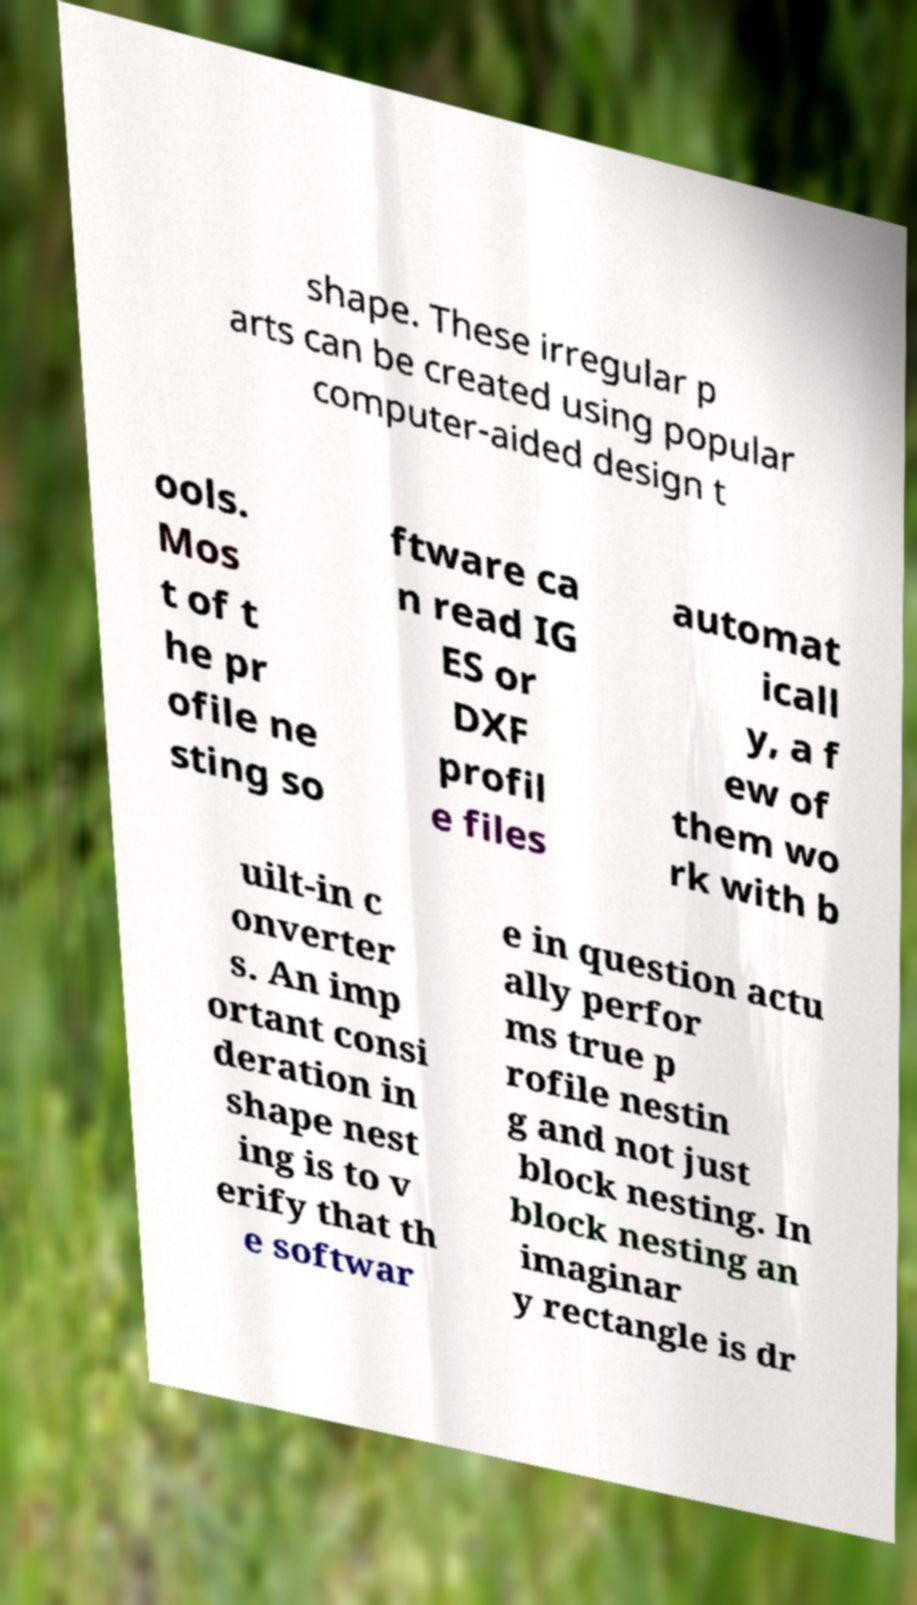What messages or text are displayed in this image? I need them in a readable, typed format. shape. These irregular p arts can be created using popular computer-aided design t ools. Mos t of t he pr ofile ne sting so ftware ca n read IG ES or DXF profil e files automat icall y, a f ew of them wo rk with b uilt-in c onverter s. An imp ortant consi deration in shape nest ing is to v erify that th e softwar e in question actu ally perfor ms true p rofile nestin g and not just block nesting. In block nesting an imaginar y rectangle is dr 